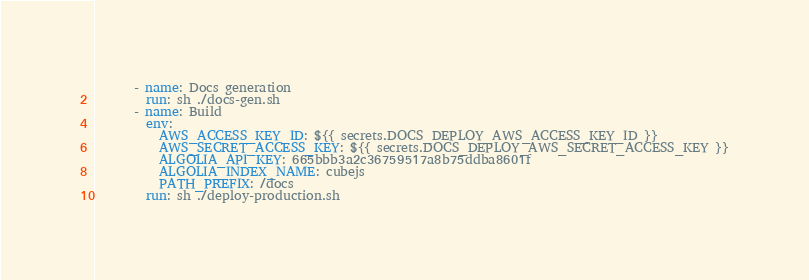<code> <loc_0><loc_0><loc_500><loc_500><_YAML_>      - name: Docs generation
        run: sh ./docs-gen.sh
      - name: Build
        env:
          AWS_ACCESS_KEY_ID: ${{ secrets.DOCS_DEPLOY_AWS_ACCESS_KEY_ID }}
          AWS_SECRET_ACCESS_KEY: ${{ secrets.DOCS_DEPLOY_AWS_SECRET_ACCESS_KEY }}
          ALGOLIA_API_KEY: 665bbb3a2c36759517a8b75ddba8601f
          ALGOLIA_INDEX_NAME: cubejs
          PATH_PREFIX: /docs
        run: sh ./deploy-production.sh
</code> 